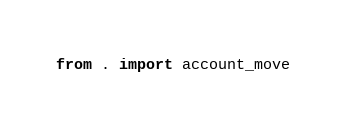<code> <loc_0><loc_0><loc_500><loc_500><_Python_>from . import account_move</code> 